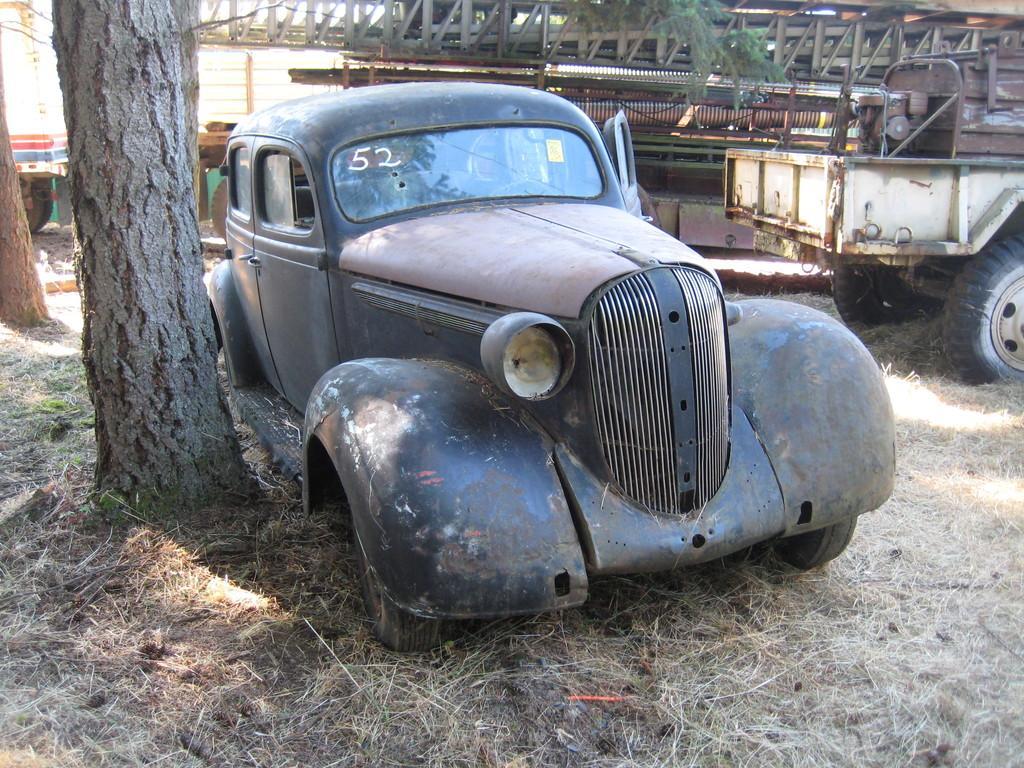Please provide a concise description of this image. In this image I can see ground and on it I can see two trees and few vehicles. 